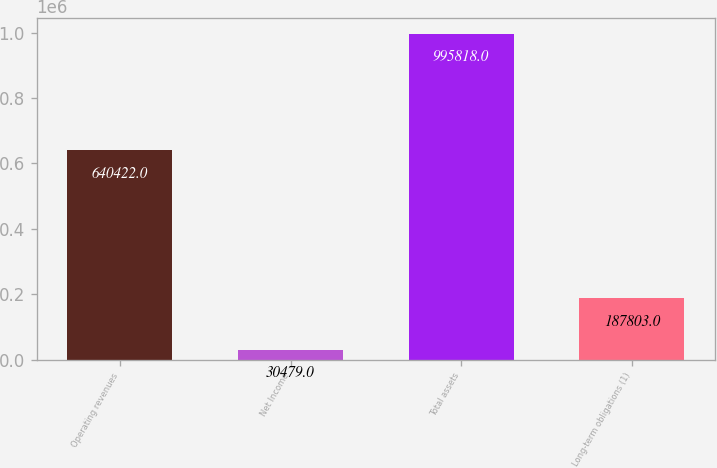Convert chart to OTSL. <chart><loc_0><loc_0><loc_500><loc_500><bar_chart><fcel>Operating revenues<fcel>Net Income<fcel>Total assets<fcel>Long-term obligations (1)<nl><fcel>640422<fcel>30479<fcel>995818<fcel>187803<nl></chart> 